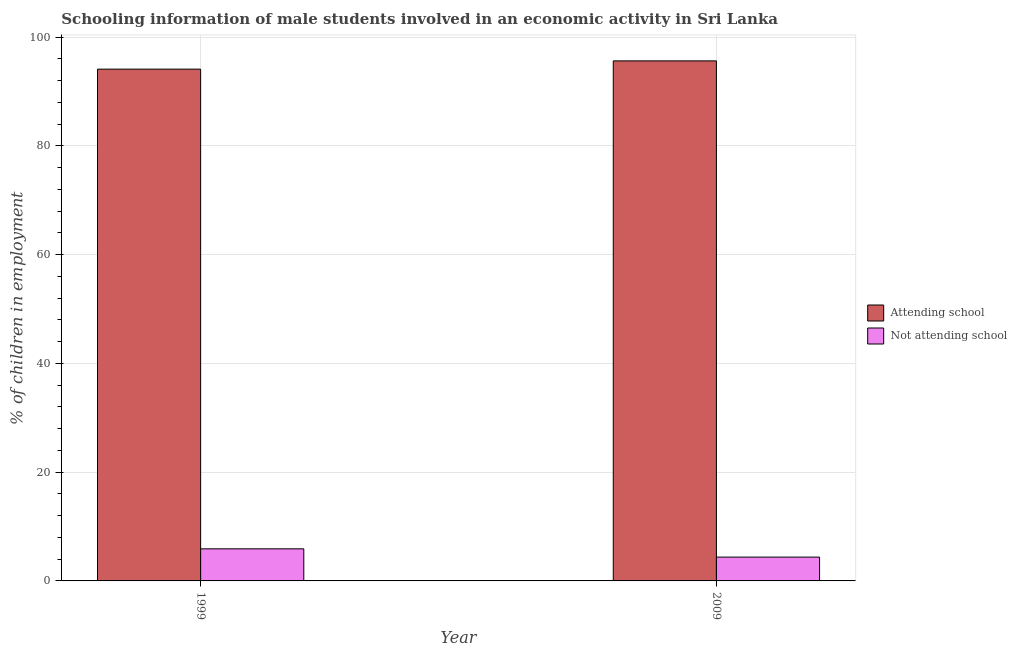Are the number of bars on each tick of the X-axis equal?
Provide a succinct answer. Yes. What is the label of the 1st group of bars from the left?
Your answer should be very brief. 1999. What is the percentage of employed males who are not attending school in 2009?
Offer a terse response. 4.38. Across all years, what is the minimum percentage of employed males who are attending school?
Ensure brevity in your answer.  94.1. In which year was the percentage of employed males who are not attending school maximum?
Make the answer very short. 1999. What is the total percentage of employed males who are not attending school in the graph?
Keep it short and to the point. 10.28. What is the difference between the percentage of employed males who are not attending school in 1999 and that in 2009?
Your response must be concise. 1.52. What is the difference between the percentage of employed males who are not attending school in 2009 and the percentage of employed males who are attending school in 1999?
Ensure brevity in your answer.  -1.52. What is the average percentage of employed males who are not attending school per year?
Give a very brief answer. 5.14. In the year 2009, what is the difference between the percentage of employed males who are not attending school and percentage of employed males who are attending school?
Your answer should be very brief. 0. What is the ratio of the percentage of employed males who are attending school in 1999 to that in 2009?
Offer a very short reply. 0.98. What does the 2nd bar from the left in 1999 represents?
Make the answer very short. Not attending school. What does the 2nd bar from the right in 2009 represents?
Ensure brevity in your answer.  Attending school. How many bars are there?
Your answer should be very brief. 4. Are all the bars in the graph horizontal?
Provide a succinct answer. No. What is the difference between two consecutive major ticks on the Y-axis?
Provide a succinct answer. 20. How many legend labels are there?
Give a very brief answer. 2. What is the title of the graph?
Provide a succinct answer. Schooling information of male students involved in an economic activity in Sri Lanka. What is the label or title of the Y-axis?
Your answer should be compact. % of children in employment. What is the % of children in employment in Attending school in 1999?
Your response must be concise. 94.1. What is the % of children in employment in Not attending school in 1999?
Keep it short and to the point. 5.9. What is the % of children in employment in Attending school in 2009?
Give a very brief answer. 95.62. What is the % of children in employment of Not attending school in 2009?
Provide a succinct answer. 4.38. Across all years, what is the maximum % of children in employment in Attending school?
Ensure brevity in your answer.  95.62. Across all years, what is the maximum % of children in employment of Not attending school?
Make the answer very short. 5.9. Across all years, what is the minimum % of children in employment in Attending school?
Offer a very short reply. 94.1. Across all years, what is the minimum % of children in employment in Not attending school?
Offer a very short reply. 4.38. What is the total % of children in employment of Attending school in the graph?
Offer a terse response. 189.72. What is the total % of children in employment of Not attending school in the graph?
Offer a very short reply. 10.28. What is the difference between the % of children in employment in Attending school in 1999 and that in 2009?
Keep it short and to the point. -1.52. What is the difference between the % of children in employment in Not attending school in 1999 and that in 2009?
Your answer should be very brief. 1.52. What is the difference between the % of children in employment of Attending school in 1999 and the % of children in employment of Not attending school in 2009?
Keep it short and to the point. 89.72. What is the average % of children in employment in Attending school per year?
Offer a terse response. 94.86. What is the average % of children in employment in Not attending school per year?
Offer a terse response. 5.14. In the year 1999, what is the difference between the % of children in employment of Attending school and % of children in employment of Not attending school?
Keep it short and to the point. 88.2. In the year 2009, what is the difference between the % of children in employment in Attending school and % of children in employment in Not attending school?
Ensure brevity in your answer.  91.24. What is the ratio of the % of children in employment of Attending school in 1999 to that in 2009?
Offer a terse response. 0.98. What is the ratio of the % of children in employment of Not attending school in 1999 to that in 2009?
Offer a terse response. 1.35. What is the difference between the highest and the second highest % of children in employment in Attending school?
Your answer should be compact. 1.52. What is the difference between the highest and the second highest % of children in employment in Not attending school?
Make the answer very short. 1.52. What is the difference between the highest and the lowest % of children in employment of Attending school?
Your answer should be very brief. 1.52. What is the difference between the highest and the lowest % of children in employment of Not attending school?
Your answer should be very brief. 1.52. 